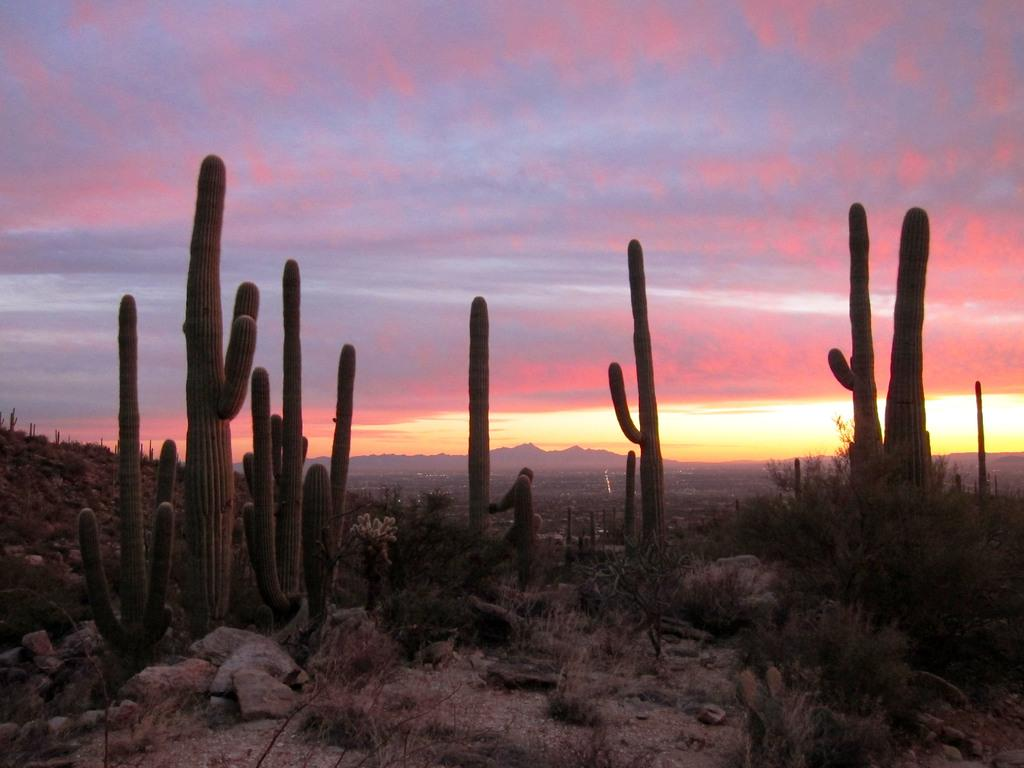What type of plants are in the image? There are cactus plants in the image. What can be seen on the ground in the image? There are rocks and stones visible on a path. How would you describe the sky in the image? The sky is cloudy. What type of grape is being used to make the loaf of bread in the image? There is no grape or loaf of bread present in the image. What kitchen appliance can be seen in the image? There is no kitchen appliance present in the image. 